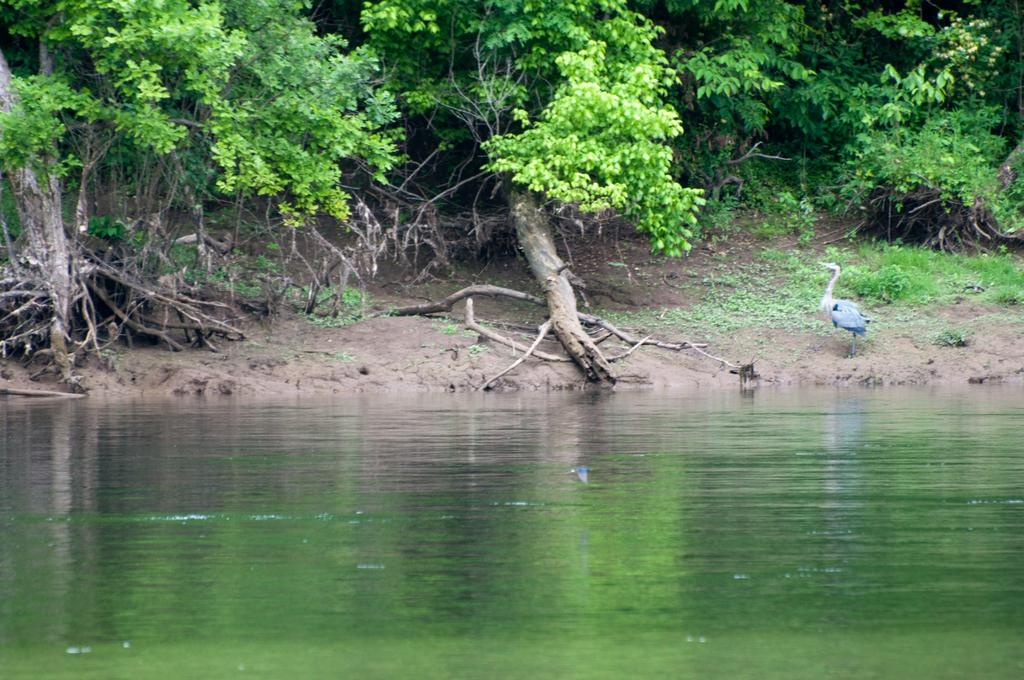What is the primary element visible in the image? There is water in the image. What type of vegetation can be seen in the image? There are trees visible in the image. What object is present on the sand in the image? There is a crane on the sand in the image. Can you see any rabbits in the image? There are no rabbits present in the image. What type of flame can be seen coming from the crane in the image? There is no flame present in the image; it features a crane on the sand. 